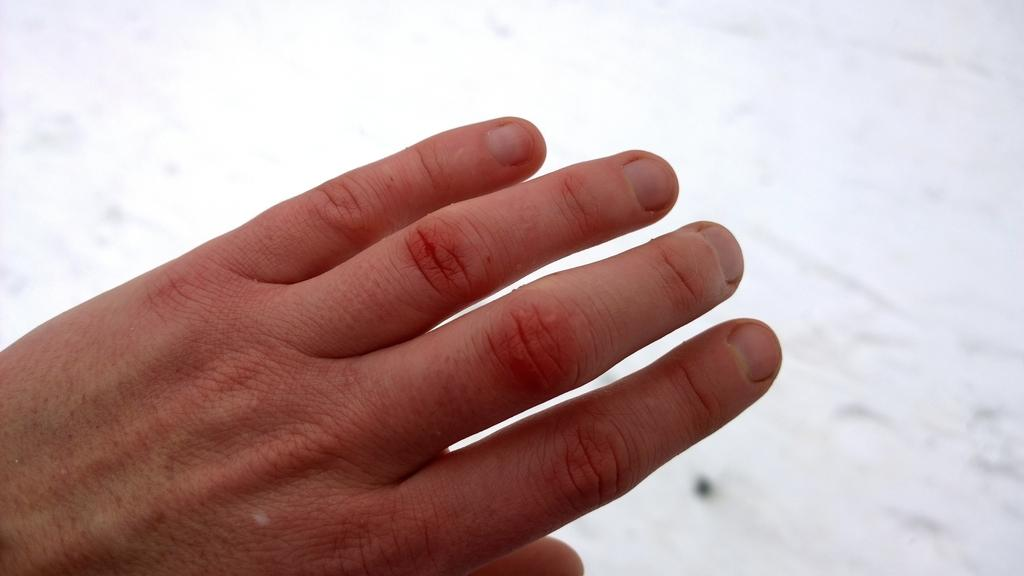What can be seen in the image? There is a hand of a person in the image. What color is the background of the image? The background of the image is white. What type of doctor is examining the hand in the image? There is no doctor present in the image, and the hand is not being examined by anyone. 